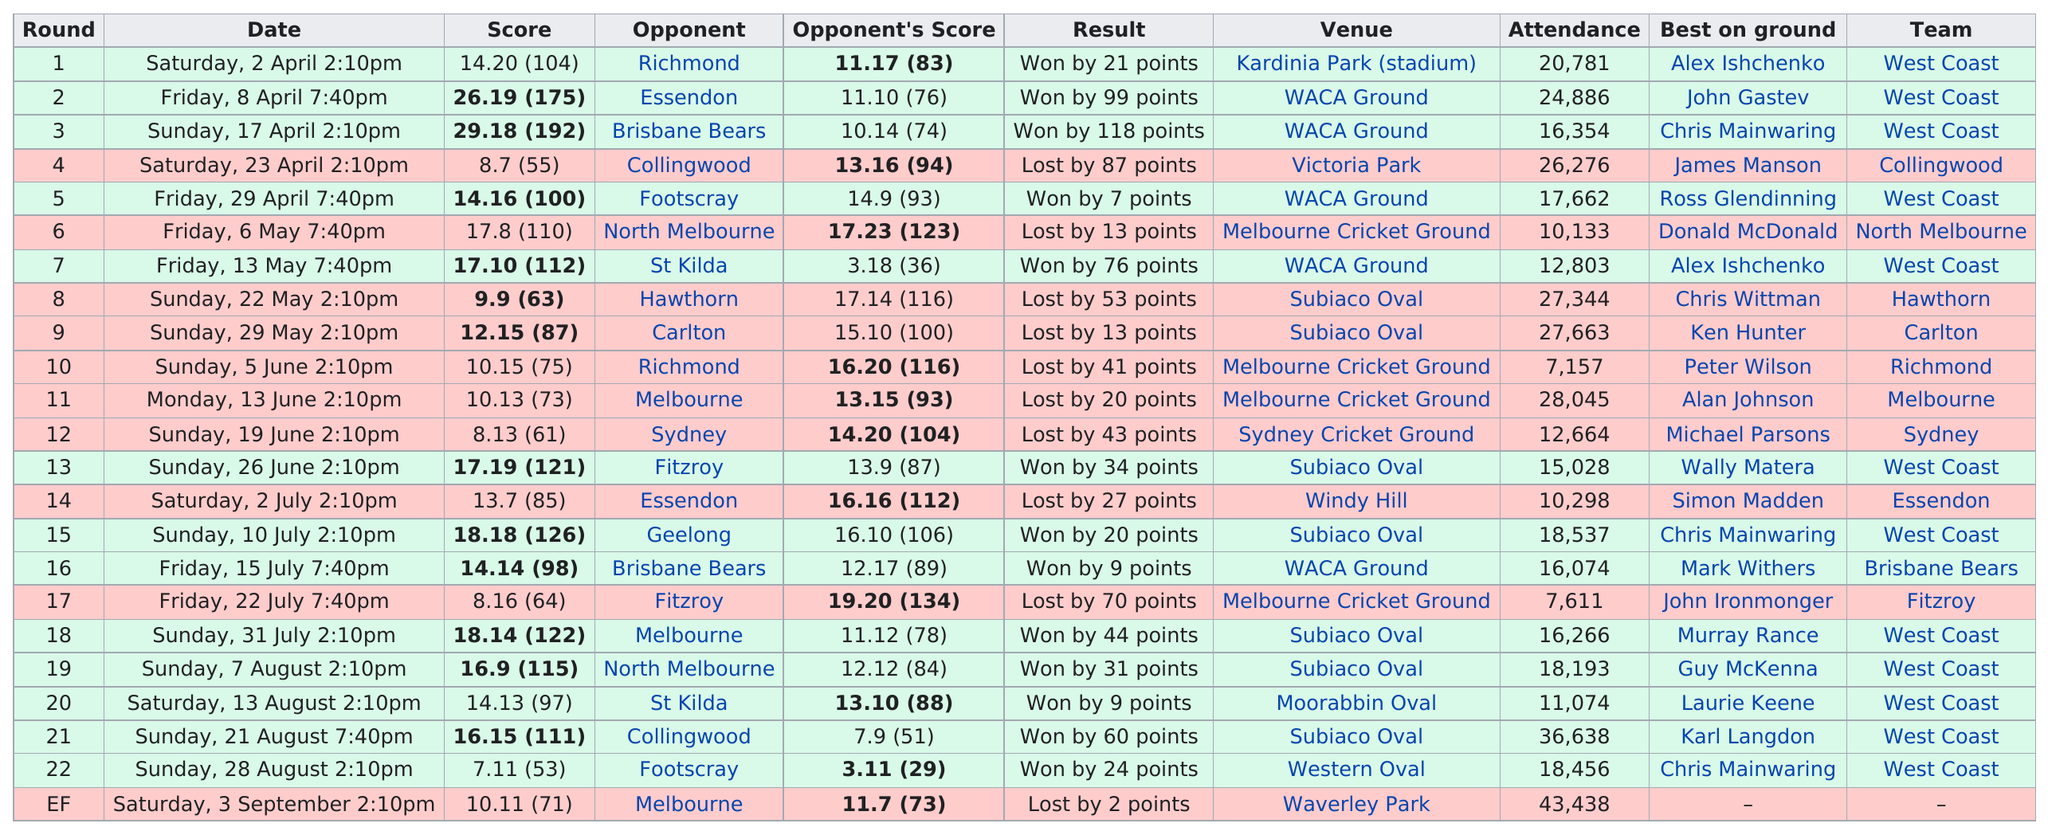Outline some significant characteristics in this image. In the period before July 31, a total of 17 rounds were played. The last win occurred on August 28. Waverley Park was the venue where the only round was held with more than 40,000 people in attendance. This season, the team has lost a total of ten games. This team achieved an incredible victory with a staggering margin of 118 points, the largest in their history. 